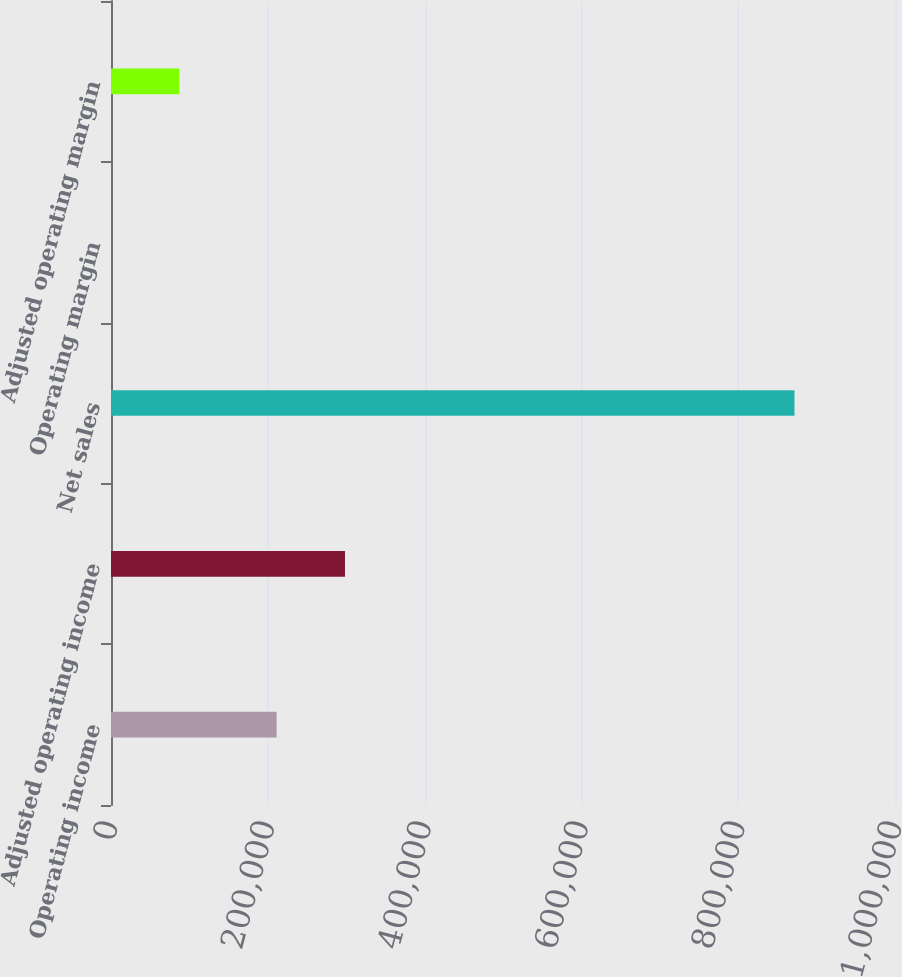Convert chart. <chart><loc_0><loc_0><loc_500><loc_500><bar_chart><fcel>Operating income<fcel>Adjusted operating income<fcel>Net sales<fcel>Operating margin<fcel>Adjusted operating margin<nl><fcel>211256<fcel>298435<fcel>871814<fcel>24.2<fcel>87203.2<nl></chart> 